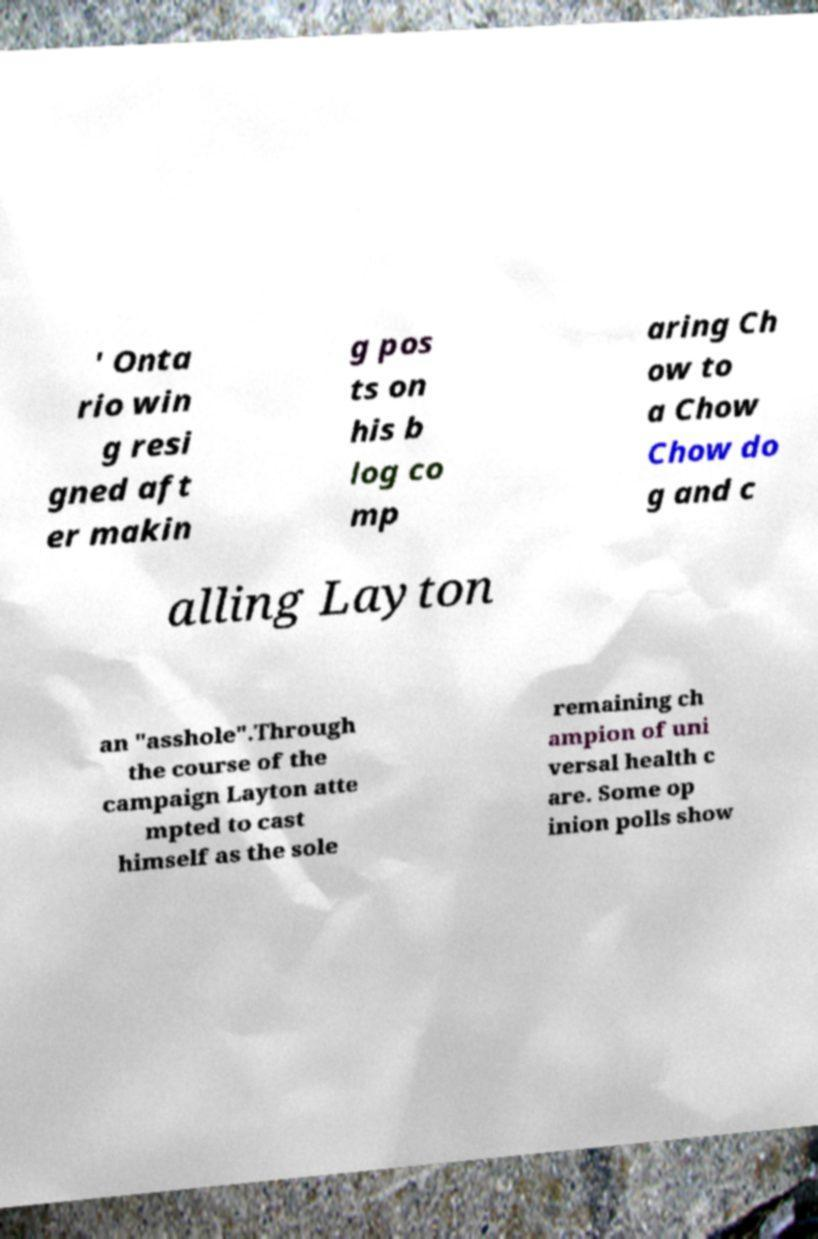Please read and relay the text visible in this image. What does it say? ' Onta rio win g resi gned aft er makin g pos ts on his b log co mp aring Ch ow to a Chow Chow do g and c alling Layton an "asshole".Through the course of the campaign Layton atte mpted to cast himself as the sole remaining ch ampion of uni versal health c are. Some op inion polls show 